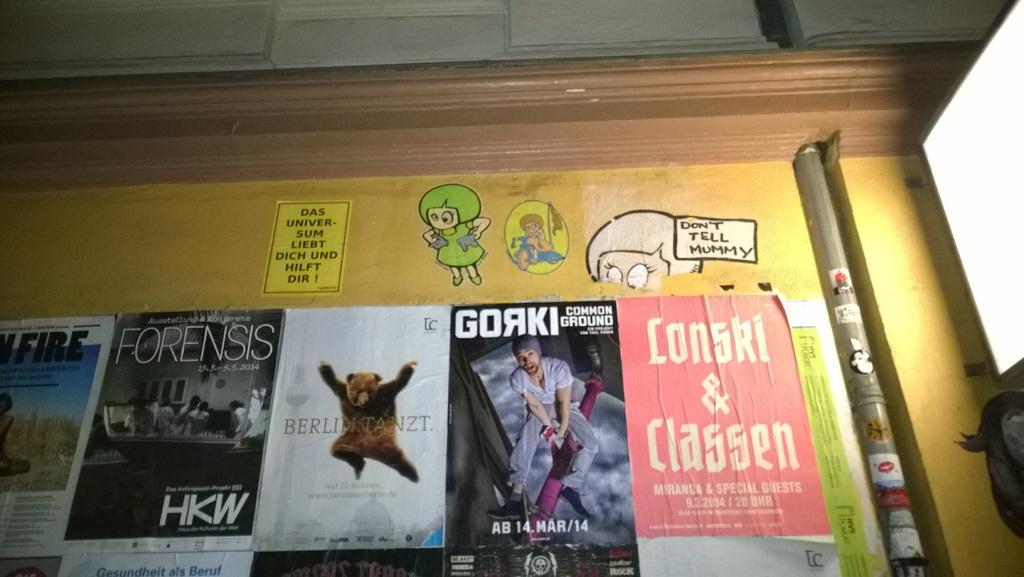What does the cartoon at the top of the board say you should do to mummy?
Your answer should be compact. Don't tell mummy. What is the name of the book with a man on the cover?
Provide a succinct answer. Gorki. 